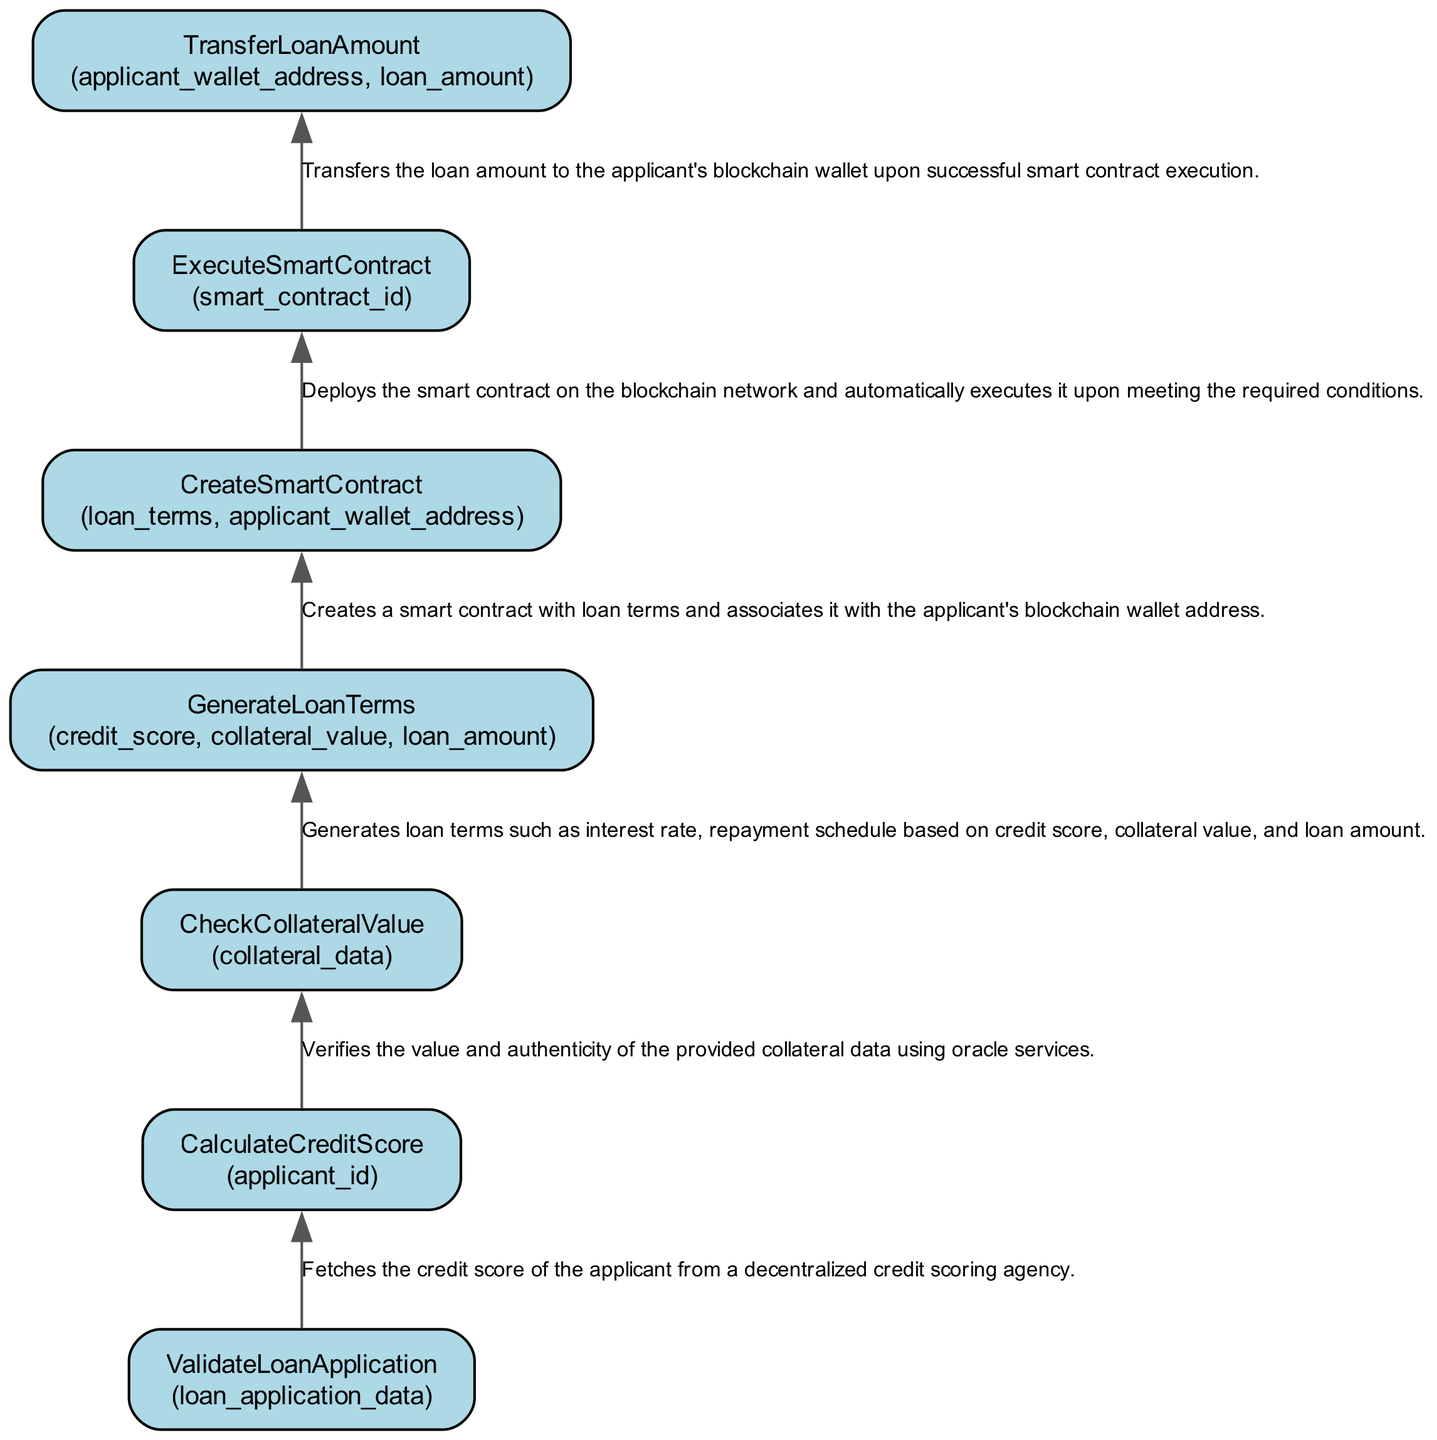What is the first step in the loan disbursement process? The first step shown in the diagram is "ValidateLoanApplication," which indicates that the loan application data is validated for completeness and correctness.
Answer: ValidateLoanApplication How many nodes are present in the diagram? By counting each function represented in the diagram, we find that there are a total of seven nodes corresponding to each step in the loan process.
Answer: 7 What parameters are used in the "CreateSmartContract" function? The parameters listed for the “CreateSmartContract” function are "loan_terms" and "applicant_wallet_address," which are necessary to create and associate the smart contract.
Answer: loan_terms, applicant_wallet_address Which function follows the "CheckCollateralValue" function? The function that follows "CheckCollateralValue" is "GenerateLoanTerms," indicating that after collateral verification, loan terms are established.
Answer: GenerateLoanTerms What does the "ExecuteSmartContract" function do? The "ExecuteSmartContract" function deploys the smart contract on the blockchain and automatically executes it when the specified conditions are met, facilitating the loan disbursement process.
Answer: Deploys and executes What is the relationship between "CalculateCreditScore" and "GenerateLoanTerms"? The relationship is that "GenerateLoanTerms" relies on the output of "CalculateCreditScore," as it uses the credit score to determine the loan conditions.
Answer: Credit score used for terms In the context of this diagram, what type of relationship exists between “CreateSmartContract” and “TransferLoanAmount”? The relationship indicates that after creating the smart contract, the next step is to "TransferLoanAmount," which signifies the flow of actions leading to loan disbursement post-execution of the contract.
Answer: Sequential relationship What could be a potential input to the "ValidateLoanApplication" function? A potential input would be "loan_application_data," which represents the information about the loan request that needs to be validated.
Answer: loan_application_data 